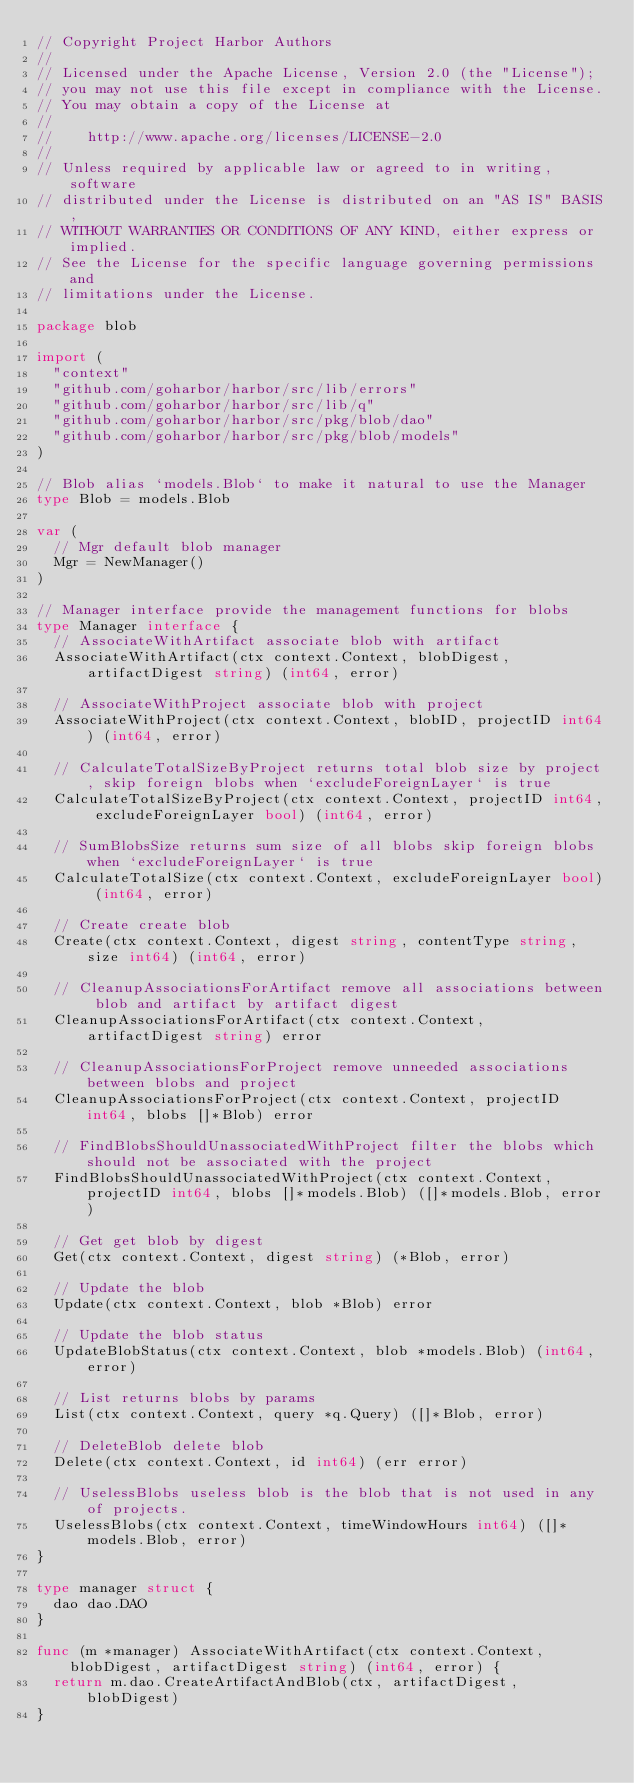<code> <loc_0><loc_0><loc_500><loc_500><_Go_>// Copyright Project Harbor Authors
//
// Licensed under the Apache License, Version 2.0 (the "License");
// you may not use this file except in compliance with the License.
// You may obtain a copy of the License at
//
//    http://www.apache.org/licenses/LICENSE-2.0
//
// Unless required by applicable law or agreed to in writing, software
// distributed under the License is distributed on an "AS IS" BASIS,
// WITHOUT WARRANTIES OR CONDITIONS OF ANY KIND, either express or implied.
// See the License for the specific language governing permissions and
// limitations under the License.

package blob

import (
	"context"
	"github.com/goharbor/harbor/src/lib/errors"
	"github.com/goharbor/harbor/src/lib/q"
	"github.com/goharbor/harbor/src/pkg/blob/dao"
	"github.com/goharbor/harbor/src/pkg/blob/models"
)

// Blob alias `models.Blob` to make it natural to use the Manager
type Blob = models.Blob

var (
	// Mgr default blob manager
	Mgr = NewManager()
)

// Manager interface provide the management functions for blobs
type Manager interface {
	// AssociateWithArtifact associate blob with artifact
	AssociateWithArtifact(ctx context.Context, blobDigest, artifactDigest string) (int64, error)

	// AssociateWithProject associate blob with project
	AssociateWithProject(ctx context.Context, blobID, projectID int64) (int64, error)

	// CalculateTotalSizeByProject returns total blob size by project, skip foreign blobs when `excludeForeignLayer` is true
	CalculateTotalSizeByProject(ctx context.Context, projectID int64, excludeForeignLayer bool) (int64, error)

	// SumBlobsSize returns sum size of all blobs skip foreign blobs when `excludeForeignLayer` is true
	CalculateTotalSize(ctx context.Context, excludeForeignLayer bool) (int64, error)

	// Create create blob
	Create(ctx context.Context, digest string, contentType string, size int64) (int64, error)

	// CleanupAssociationsForArtifact remove all associations between blob and artifact by artifact digest
	CleanupAssociationsForArtifact(ctx context.Context, artifactDigest string) error

	// CleanupAssociationsForProject remove unneeded associations between blobs and project
	CleanupAssociationsForProject(ctx context.Context, projectID int64, blobs []*Blob) error

	// FindBlobsShouldUnassociatedWithProject filter the blobs which should not be associated with the project
	FindBlobsShouldUnassociatedWithProject(ctx context.Context, projectID int64, blobs []*models.Blob) ([]*models.Blob, error)

	// Get get blob by digest
	Get(ctx context.Context, digest string) (*Blob, error)

	// Update the blob
	Update(ctx context.Context, blob *Blob) error

	// Update the blob status
	UpdateBlobStatus(ctx context.Context, blob *models.Blob) (int64, error)

	// List returns blobs by params
	List(ctx context.Context, query *q.Query) ([]*Blob, error)

	// DeleteBlob delete blob
	Delete(ctx context.Context, id int64) (err error)

	// UselessBlobs useless blob is the blob that is not used in any of projects.
	UselessBlobs(ctx context.Context, timeWindowHours int64) ([]*models.Blob, error)
}

type manager struct {
	dao dao.DAO
}

func (m *manager) AssociateWithArtifact(ctx context.Context, blobDigest, artifactDigest string) (int64, error) {
	return m.dao.CreateArtifactAndBlob(ctx, artifactDigest, blobDigest)
}
</code> 